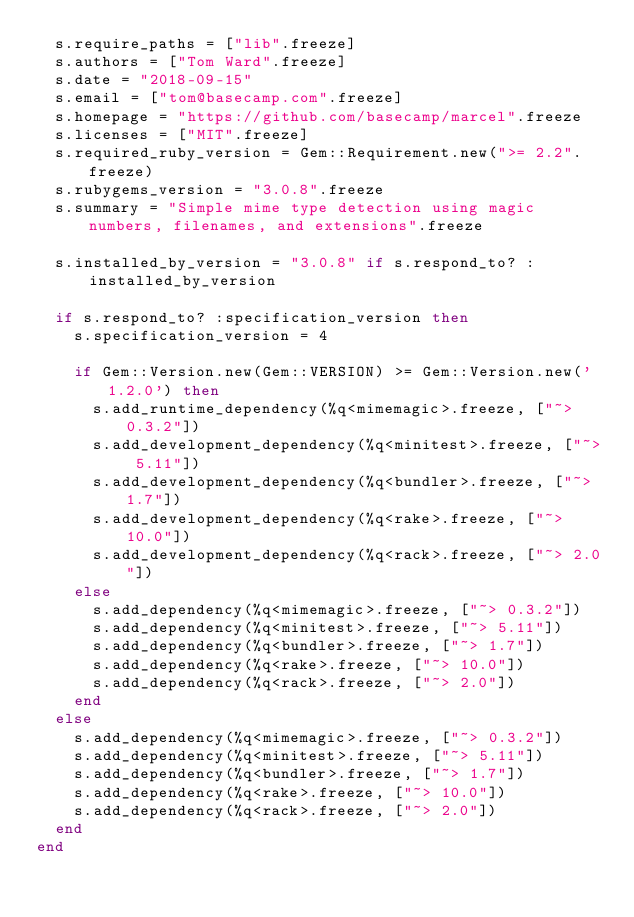Convert code to text. <code><loc_0><loc_0><loc_500><loc_500><_Ruby_>  s.require_paths = ["lib".freeze]
  s.authors = ["Tom Ward".freeze]
  s.date = "2018-09-15"
  s.email = ["tom@basecamp.com".freeze]
  s.homepage = "https://github.com/basecamp/marcel".freeze
  s.licenses = ["MIT".freeze]
  s.required_ruby_version = Gem::Requirement.new(">= 2.2".freeze)
  s.rubygems_version = "3.0.8".freeze
  s.summary = "Simple mime type detection using magic numbers, filenames, and extensions".freeze

  s.installed_by_version = "3.0.8" if s.respond_to? :installed_by_version

  if s.respond_to? :specification_version then
    s.specification_version = 4

    if Gem::Version.new(Gem::VERSION) >= Gem::Version.new('1.2.0') then
      s.add_runtime_dependency(%q<mimemagic>.freeze, ["~> 0.3.2"])
      s.add_development_dependency(%q<minitest>.freeze, ["~> 5.11"])
      s.add_development_dependency(%q<bundler>.freeze, ["~> 1.7"])
      s.add_development_dependency(%q<rake>.freeze, ["~> 10.0"])
      s.add_development_dependency(%q<rack>.freeze, ["~> 2.0"])
    else
      s.add_dependency(%q<mimemagic>.freeze, ["~> 0.3.2"])
      s.add_dependency(%q<minitest>.freeze, ["~> 5.11"])
      s.add_dependency(%q<bundler>.freeze, ["~> 1.7"])
      s.add_dependency(%q<rake>.freeze, ["~> 10.0"])
      s.add_dependency(%q<rack>.freeze, ["~> 2.0"])
    end
  else
    s.add_dependency(%q<mimemagic>.freeze, ["~> 0.3.2"])
    s.add_dependency(%q<minitest>.freeze, ["~> 5.11"])
    s.add_dependency(%q<bundler>.freeze, ["~> 1.7"])
    s.add_dependency(%q<rake>.freeze, ["~> 10.0"])
    s.add_dependency(%q<rack>.freeze, ["~> 2.0"])
  end
end
</code> 